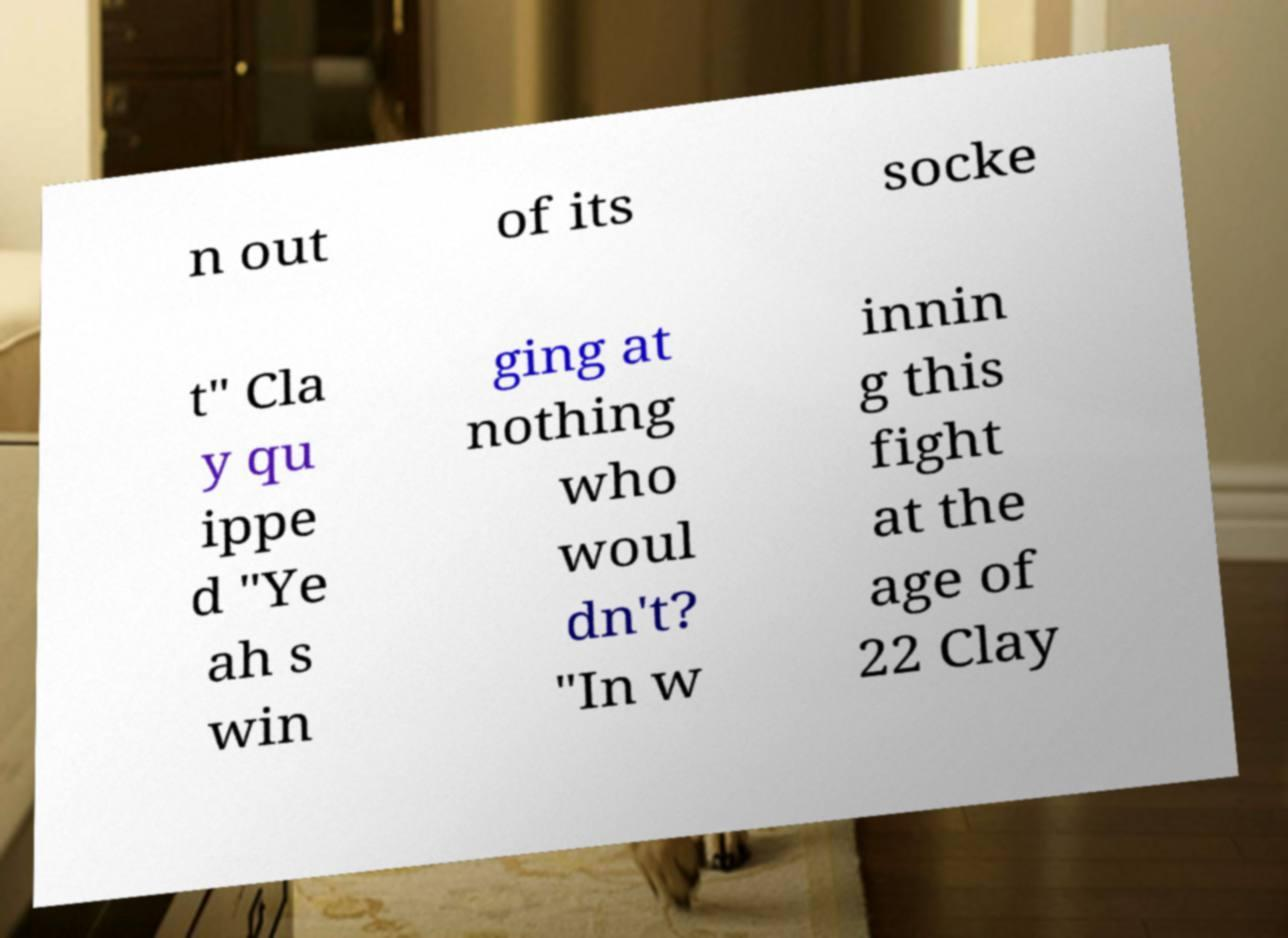Please read and relay the text visible in this image. What does it say? n out of its socke t" Cla y qu ippe d "Ye ah s win ging at nothing who woul dn't? "In w innin g this fight at the age of 22 Clay 